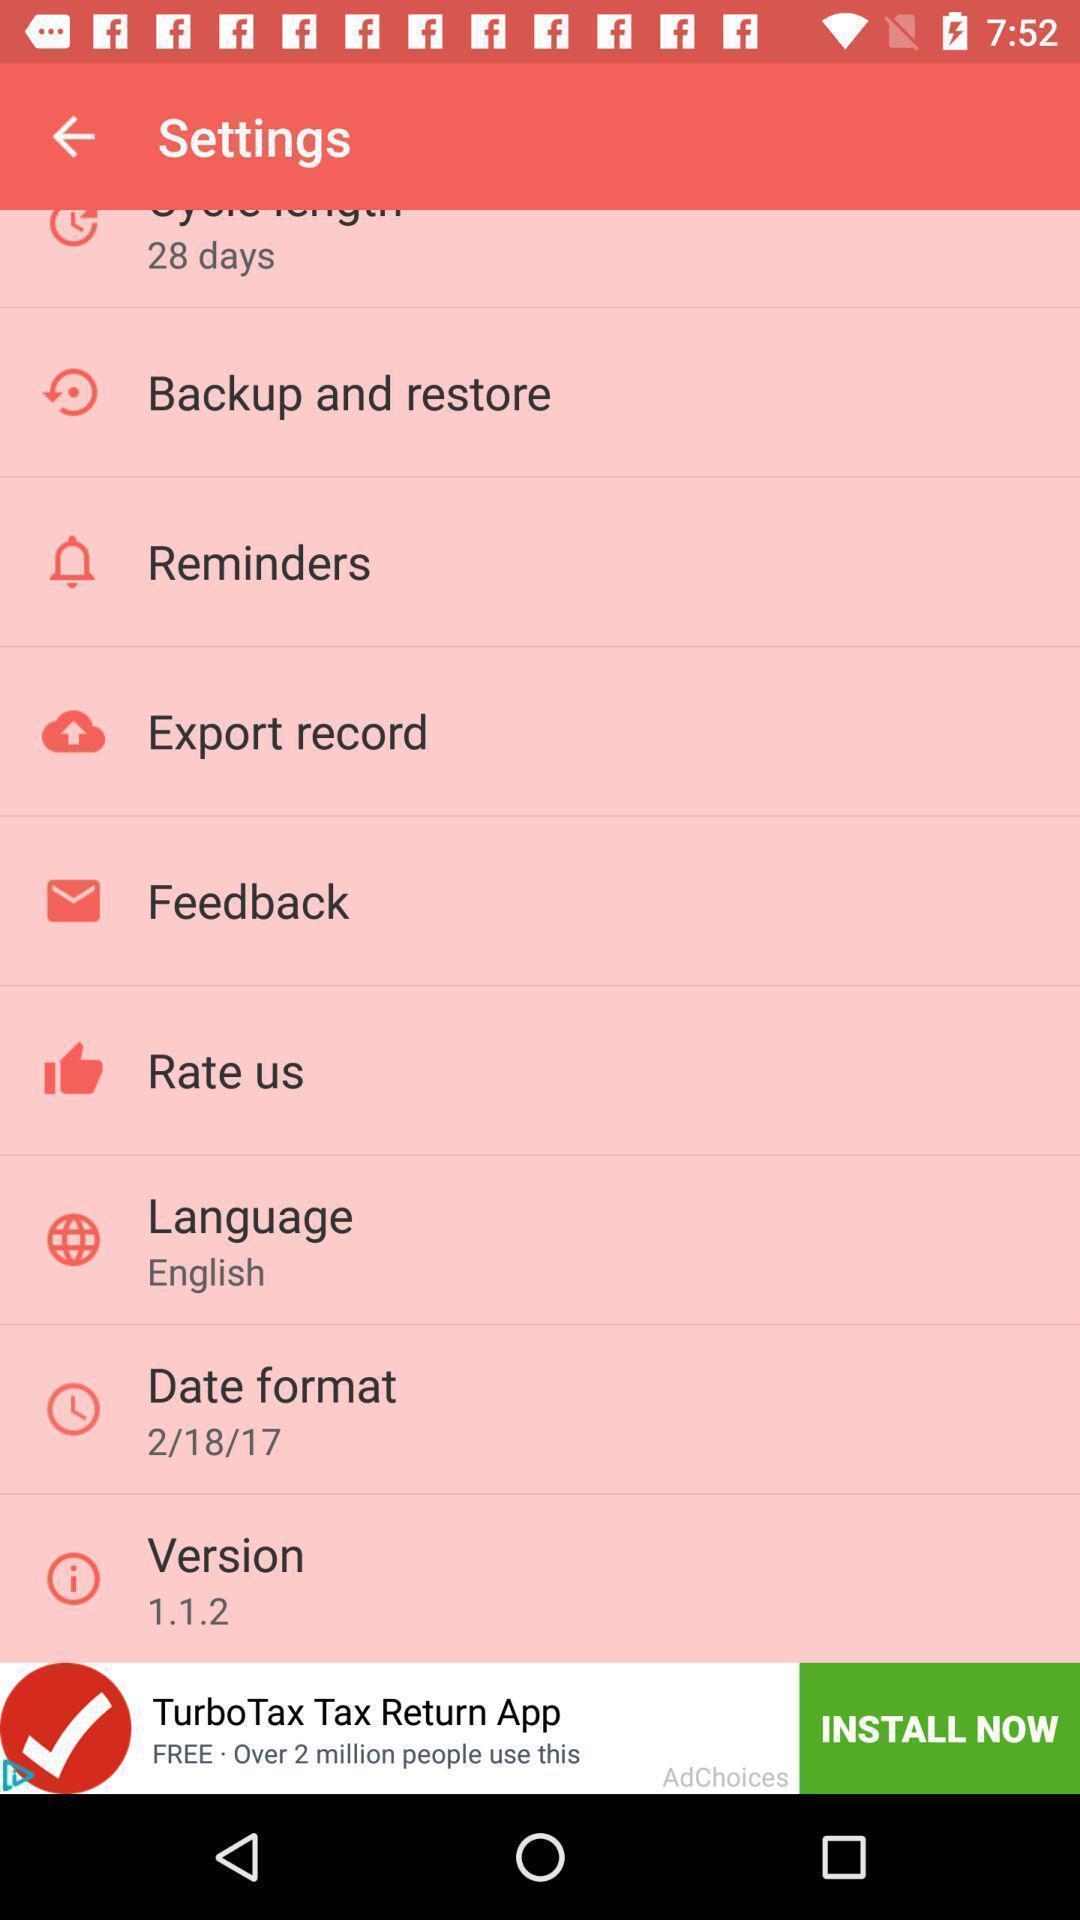Describe the key features of this screenshot. Settings of an social app. 